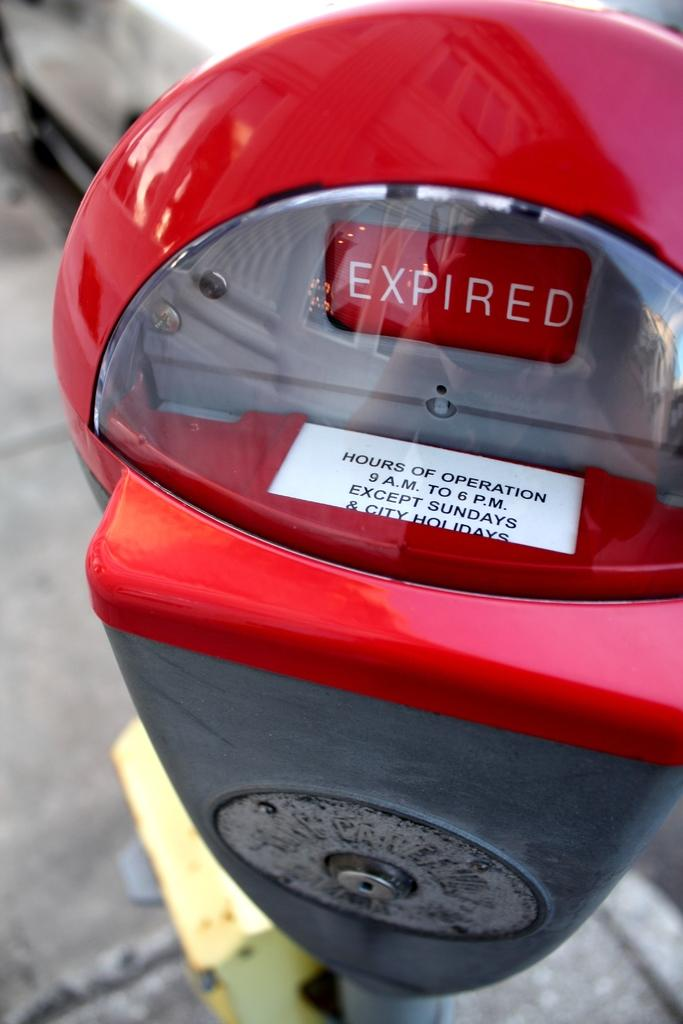Provide a one-sentence caption for the provided image. a parking meter that has an expired tag on it and hours of operation. 